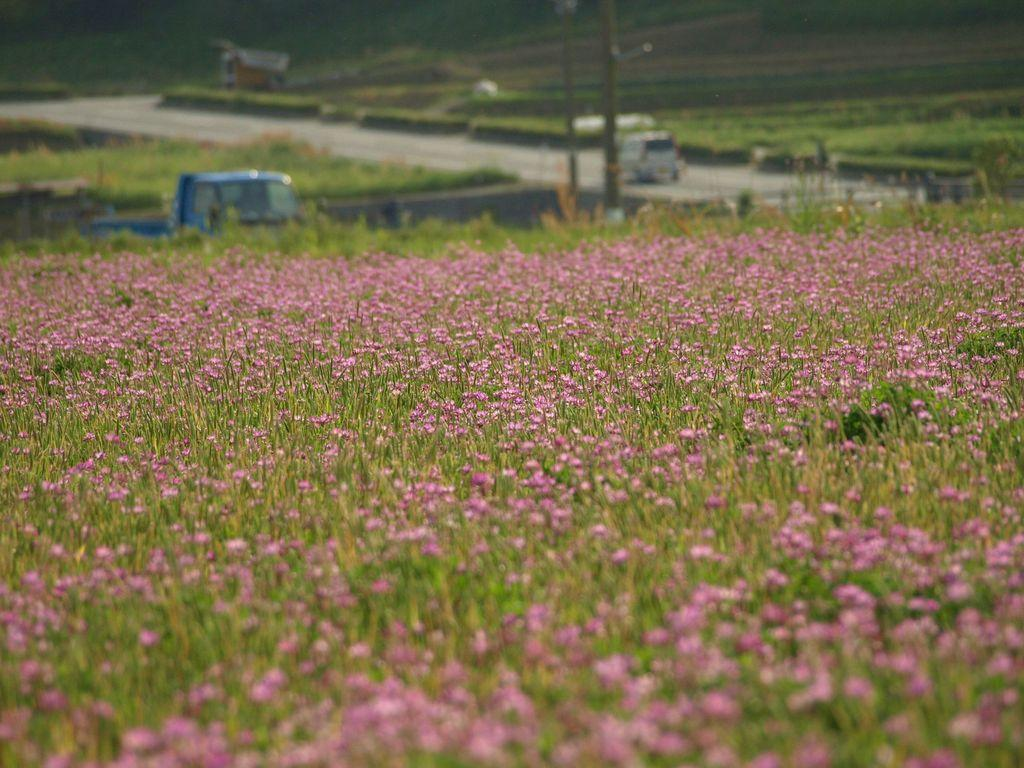What type of living organisms can be seen in the image? Plants and flowers are visible in the image. How would you describe the background of the image? The background of the image is blurry. What can be seen on the road in the background? Vehicles are visible on the road in the background. What other objects are present in the background? Poles and additional plants are present in the background. What type of net is being used to catch the fish in the image? There is no net or fish present in the image; it features plants, flowers, and various background elements. 